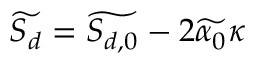Convert formula to latex. <formula><loc_0><loc_0><loc_500><loc_500>\widetilde { S _ { d } } = \widetilde { S _ { d , 0 } } - 2 \widetilde { \alpha _ { 0 } } \kappa</formula> 